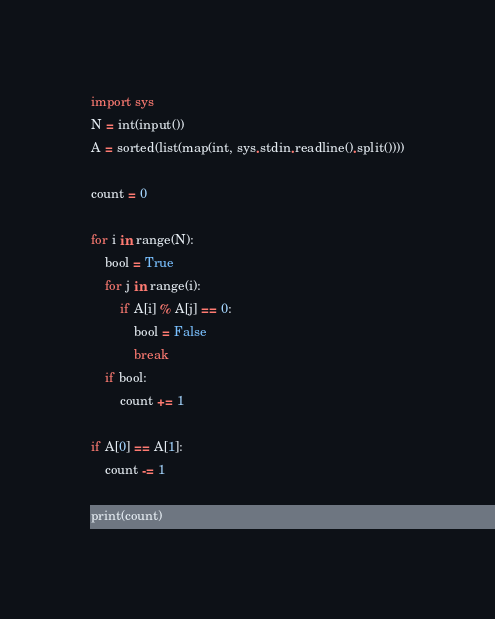<code> <loc_0><loc_0><loc_500><loc_500><_Python_>import sys
N = int(input())
A = sorted(list(map(int, sys.stdin.readline().split())))

count = 0

for i in range(N):
    bool = True
    for j in range(i):
        if A[i] % A[j] == 0:
            bool = False
            break
    if bool:
        count += 1
        
if A[0] == A[1]:
    count -= 1
        
print(count)
</code> 